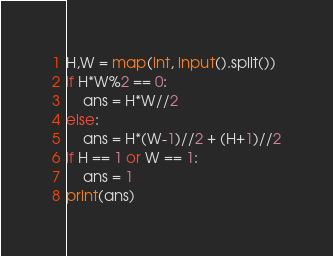Convert code to text. <code><loc_0><loc_0><loc_500><loc_500><_Python_>H,W = map(int, input().split())
if H*W%2 == 0:
    ans = H*W//2
else:
    ans = H*(W-1)//2 + (H+1)//2
if H == 1 or W == 1:
    ans = 1
print(ans)</code> 